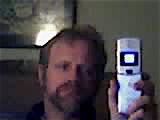What is the person holding?
Write a very short answer. Phone. Is the picture clear?
Be succinct. No. Does this person look happy?
Quick response, please. No. 